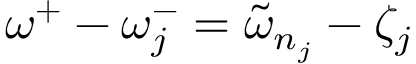Convert formula to latex. <formula><loc_0><loc_0><loc_500><loc_500>\omega ^ { + } - \omega _ { j } ^ { - } = \tilde { \omega } _ { n _ { j } } - \zeta _ { j }</formula> 